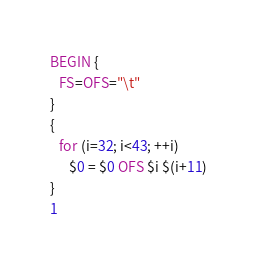Convert code to text. <code><loc_0><loc_0><loc_500><loc_500><_Awk_>BEGIN {
   FS=OFS="\t"
}
{
   for (i=32; i<43; ++i)
      $0 = $0 OFS $i $(i+11)
}
1
</code> 